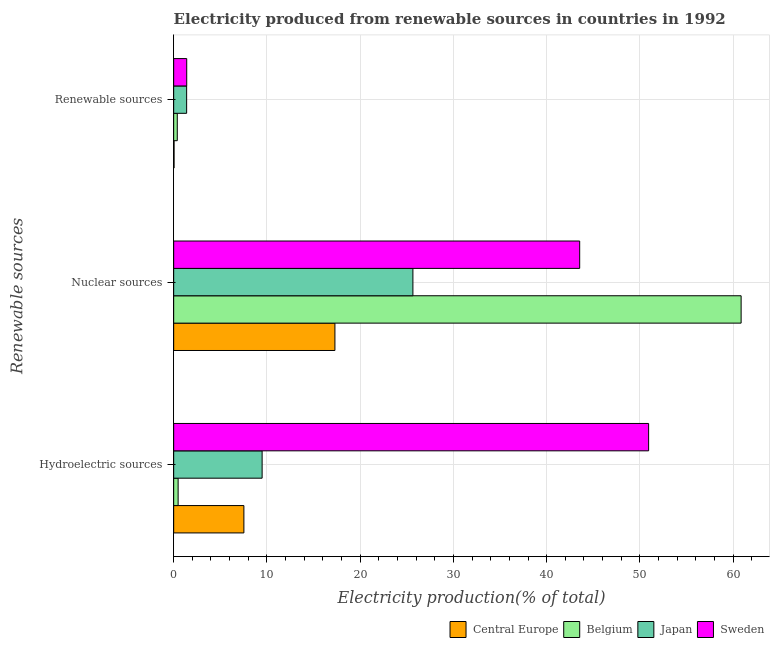Are the number of bars on each tick of the Y-axis equal?
Make the answer very short. Yes. What is the label of the 2nd group of bars from the top?
Offer a very short reply. Nuclear sources. What is the percentage of electricity produced by nuclear sources in Belgium?
Offer a terse response. 60.85. Across all countries, what is the maximum percentage of electricity produced by renewable sources?
Make the answer very short. 1.4. Across all countries, what is the minimum percentage of electricity produced by renewable sources?
Offer a very short reply. 0.04. In which country was the percentage of electricity produced by nuclear sources minimum?
Your response must be concise. Central Europe. What is the total percentage of electricity produced by nuclear sources in the graph?
Your answer should be very brief. 147.34. What is the difference between the percentage of electricity produced by renewable sources in Sweden and that in Central Europe?
Provide a succinct answer. 1.36. What is the difference between the percentage of electricity produced by hydroelectric sources in Central Europe and the percentage of electricity produced by renewable sources in Japan?
Keep it short and to the point. 6.14. What is the average percentage of electricity produced by renewable sources per country?
Keep it short and to the point. 0.8. What is the difference between the percentage of electricity produced by nuclear sources and percentage of electricity produced by hydroelectric sources in Central Europe?
Keep it short and to the point. 9.76. In how many countries, is the percentage of electricity produced by nuclear sources greater than 48 %?
Make the answer very short. 1. What is the ratio of the percentage of electricity produced by nuclear sources in Japan to that in Belgium?
Keep it short and to the point. 0.42. Is the percentage of electricity produced by hydroelectric sources in Sweden less than that in Belgium?
Make the answer very short. No. Is the difference between the percentage of electricity produced by nuclear sources in Sweden and Japan greater than the difference between the percentage of electricity produced by renewable sources in Sweden and Japan?
Provide a short and direct response. Yes. What is the difference between the highest and the second highest percentage of electricity produced by renewable sources?
Ensure brevity in your answer.  0.01. What is the difference between the highest and the lowest percentage of electricity produced by hydroelectric sources?
Offer a very short reply. 50.46. In how many countries, is the percentage of electricity produced by hydroelectric sources greater than the average percentage of electricity produced by hydroelectric sources taken over all countries?
Provide a succinct answer. 1. What does the 1st bar from the bottom in Hydroelectric sources represents?
Provide a succinct answer. Central Europe. Is it the case that in every country, the sum of the percentage of electricity produced by hydroelectric sources and percentage of electricity produced by nuclear sources is greater than the percentage of electricity produced by renewable sources?
Your response must be concise. Yes. How many bars are there?
Offer a terse response. 12. How many countries are there in the graph?
Give a very brief answer. 4. What is the difference between two consecutive major ticks on the X-axis?
Make the answer very short. 10. Are the values on the major ticks of X-axis written in scientific E-notation?
Provide a short and direct response. No. Does the graph contain grids?
Make the answer very short. Yes. How are the legend labels stacked?
Provide a short and direct response. Horizontal. What is the title of the graph?
Keep it short and to the point. Electricity produced from renewable sources in countries in 1992. What is the label or title of the X-axis?
Ensure brevity in your answer.  Electricity production(% of total). What is the label or title of the Y-axis?
Offer a terse response. Renewable sources. What is the Electricity production(% of total) in Central Europe in Hydroelectric sources?
Ensure brevity in your answer.  7.53. What is the Electricity production(% of total) in Belgium in Hydroelectric sources?
Ensure brevity in your answer.  0.48. What is the Electricity production(% of total) in Japan in Hydroelectric sources?
Give a very brief answer. 9.49. What is the Electricity production(% of total) of Sweden in Hydroelectric sources?
Your response must be concise. 50.93. What is the Electricity production(% of total) in Central Europe in Nuclear sources?
Your answer should be compact. 17.29. What is the Electricity production(% of total) of Belgium in Nuclear sources?
Provide a short and direct response. 60.85. What is the Electricity production(% of total) in Japan in Nuclear sources?
Your response must be concise. 25.65. What is the Electricity production(% of total) of Sweden in Nuclear sources?
Your response must be concise. 43.54. What is the Electricity production(% of total) in Central Europe in Renewable sources?
Keep it short and to the point. 0.04. What is the Electricity production(% of total) of Belgium in Renewable sources?
Keep it short and to the point. 0.39. What is the Electricity production(% of total) of Japan in Renewable sources?
Offer a terse response. 1.39. What is the Electricity production(% of total) of Sweden in Renewable sources?
Ensure brevity in your answer.  1.4. Across all Renewable sources, what is the maximum Electricity production(% of total) of Central Europe?
Ensure brevity in your answer.  17.29. Across all Renewable sources, what is the maximum Electricity production(% of total) of Belgium?
Provide a succinct answer. 60.85. Across all Renewable sources, what is the maximum Electricity production(% of total) in Japan?
Ensure brevity in your answer.  25.65. Across all Renewable sources, what is the maximum Electricity production(% of total) of Sweden?
Make the answer very short. 50.93. Across all Renewable sources, what is the minimum Electricity production(% of total) of Central Europe?
Offer a terse response. 0.04. Across all Renewable sources, what is the minimum Electricity production(% of total) of Belgium?
Offer a terse response. 0.39. Across all Renewable sources, what is the minimum Electricity production(% of total) in Japan?
Provide a short and direct response. 1.39. Across all Renewable sources, what is the minimum Electricity production(% of total) in Sweden?
Provide a succinct answer. 1.4. What is the total Electricity production(% of total) of Central Europe in the graph?
Ensure brevity in your answer.  24.87. What is the total Electricity production(% of total) in Belgium in the graph?
Your answer should be very brief. 61.72. What is the total Electricity production(% of total) of Japan in the graph?
Offer a very short reply. 36.53. What is the total Electricity production(% of total) in Sweden in the graph?
Offer a very short reply. 95.88. What is the difference between the Electricity production(% of total) in Central Europe in Hydroelectric sources and that in Nuclear sources?
Your answer should be very brief. -9.76. What is the difference between the Electricity production(% of total) in Belgium in Hydroelectric sources and that in Nuclear sources?
Offer a very short reply. -60.38. What is the difference between the Electricity production(% of total) in Japan in Hydroelectric sources and that in Nuclear sources?
Provide a succinct answer. -16.17. What is the difference between the Electricity production(% of total) of Sweden in Hydroelectric sources and that in Nuclear sources?
Offer a very short reply. 7.39. What is the difference between the Electricity production(% of total) in Central Europe in Hydroelectric sources and that in Renewable sources?
Your response must be concise. 7.49. What is the difference between the Electricity production(% of total) in Belgium in Hydroelectric sources and that in Renewable sources?
Provide a short and direct response. 0.09. What is the difference between the Electricity production(% of total) in Japan in Hydroelectric sources and that in Renewable sources?
Offer a terse response. 8.09. What is the difference between the Electricity production(% of total) of Sweden in Hydroelectric sources and that in Renewable sources?
Your answer should be very brief. 49.54. What is the difference between the Electricity production(% of total) in Central Europe in Nuclear sources and that in Renewable sources?
Provide a short and direct response. 17.25. What is the difference between the Electricity production(% of total) in Belgium in Nuclear sources and that in Renewable sources?
Your response must be concise. 60.47. What is the difference between the Electricity production(% of total) in Japan in Nuclear sources and that in Renewable sources?
Give a very brief answer. 24.26. What is the difference between the Electricity production(% of total) in Sweden in Nuclear sources and that in Renewable sources?
Your answer should be very brief. 42.14. What is the difference between the Electricity production(% of total) of Central Europe in Hydroelectric sources and the Electricity production(% of total) of Belgium in Nuclear sources?
Keep it short and to the point. -53.32. What is the difference between the Electricity production(% of total) in Central Europe in Hydroelectric sources and the Electricity production(% of total) in Japan in Nuclear sources?
Give a very brief answer. -18.12. What is the difference between the Electricity production(% of total) of Central Europe in Hydroelectric sources and the Electricity production(% of total) of Sweden in Nuclear sources?
Your response must be concise. -36.01. What is the difference between the Electricity production(% of total) in Belgium in Hydroelectric sources and the Electricity production(% of total) in Japan in Nuclear sources?
Keep it short and to the point. -25.18. What is the difference between the Electricity production(% of total) of Belgium in Hydroelectric sources and the Electricity production(% of total) of Sweden in Nuclear sources?
Ensure brevity in your answer.  -43.06. What is the difference between the Electricity production(% of total) of Japan in Hydroelectric sources and the Electricity production(% of total) of Sweden in Nuclear sources?
Provide a succinct answer. -34.06. What is the difference between the Electricity production(% of total) in Central Europe in Hydroelectric sources and the Electricity production(% of total) in Belgium in Renewable sources?
Ensure brevity in your answer.  7.14. What is the difference between the Electricity production(% of total) in Central Europe in Hydroelectric sources and the Electricity production(% of total) in Japan in Renewable sources?
Provide a short and direct response. 6.14. What is the difference between the Electricity production(% of total) in Central Europe in Hydroelectric sources and the Electricity production(% of total) in Sweden in Renewable sources?
Provide a short and direct response. 6.13. What is the difference between the Electricity production(% of total) in Belgium in Hydroelectric sources and the Electricity production(% of total) in Japan in Renewable sources?
Offer a very short reply. -0.91. What is the difference between the Electricity production(% of total) of Belgium in Hydroelectric sources and the Electricity production(% of total) of Sweden in Renewable sources?
Your response must be concise. -0.92. What is the difference between the Electricity production(% of total) of Japan in Hydroelectric sources and the Electricity production(% of total) of Sweden in Renewable sources?
Your answer should be compact. 8.09. What is the difference between the Electricity production(% of total) of Central Europe in Nuclear sources and the Electricity production(% of total) of Belgium in Renewable sources?
Make the answer very short. 16.91. What is the difference between the Electricity production(% of total) of Central Europe in Nuclear sources and the Electricity production(% of total) of Japan in Renewable sources?
Your answer should be very brief. 15.9. What is the difference between the Electricity production(% of total) in Central Europe in Nuclear sources and the Electricity production(% of total) in Sweden in Renewable sources?
Ensure brevity in your answer.  15.89. What is the difference between the Electricity production(% of total) of Belgium in Nuclear sources and the Electricity production(% of total) of Japan in Renewable sources?
Keep it short and to the point. 59.46. What is the difference between the Electricity production(% of total) of Belgium in Nuclear sources and the Electricity production(% of total) of Sweden in Renewable sources?
Provide a short and direct response. 59.46. What is the difference between the Electricity production(% of total) in Japan in Nuclear sources and the Electricity production(% of total) in Sweden in Renewable sources?
Offer a terse response. 24.26. What is the average Electricity production(% of total) of Central Europe per Renewable sources?
Make the answer very short. 8.29. What is the average Electricity production(% of total) of Belgium per Renewable sources?
Your answer should be very brief. 20.57. What is the average Electricity production(% of total) of Japan per Renewable sources?
Make the answer very short. 12.18. What is the average Electricity production(% of total) of Sweden per Renewable sources?
Your response must be concise. 31.96. What is the difference between the Electricity production(% of total) in Central Europe and Electricity production(% of total) in Belgium in Hydroelectric sources?
Your response must be concise. 7.05. What is the difference between the Electricity production(% of total) of Central Europe and Electricity production(% of total) of Japan in Hydroelectric sources?
Ensure brevity in your answer.  -1.95. What is the difference between the Electricity production(% of total) in Central Europe and Electricity production(% of total) in Sweden in Hydroelectric sources?
Ensure brevity in your answer.  -43.4. What is the difference between the Electricity production(% of total) in Belgium and Electricity production(% of total) in Japan in Hydroelectric sources?
Make the answer very short. -9.01. What is the difference between the Electricity production(% of total) of Belgium and Electricity production(% of total) of Sweden in Hydroelectric sources?
Give a very brief answer. -50.46. What is the difference between the Electricity production(% of total) in Japan and Electricity production(% of total) in Sweden in Hydroelectric sources?
Provide a succinct answer. -41.45. What is the difference between the Electricity production(% of total) of Central Europe and Electricity production(% of total) of Belgium in Nuclear sources?
Keep it short and to the point. -43.56. What is the difference between the Electricity production(% of total) in Central Europe and Electricity production(% of total) in Japan in Nuclear sources?
Ensure brevity in your answer.  -8.36. What is the difference between the Electricity production(% of total) of Central Europe and Electricity production(% of total) of Sweden in Nuclear sources?
Offer a very short reply. -26.25. What is the difference between the Electricity production(% of total) of Belgium and Electricity production(% of total) of Japan in Nuclear sources?
Provide a short and direct response. 35.2. What is the difference between the Electricity production(% of total) of Belgium and Electricity production(% of total) of Sweden in Nuclear sources?
Offer a terse response. 17.31. What is the difference between the Electricity production(% of total) of Japan and Electricity production(% of total) of Sweden in Nuclear sources?
Provide a short and direct response. -17.89. What is the difference between the Electricity production(% of total) of Central Europe and Electricity production(% of total) of Belgium in Renewable sources?
Provide a succinct answer. -0.34. What is the difference between the Electricity production(% of total) of Central Europe and Electricity production(% of total) of Japan in Renewable sources?
Make the answer very short. -1.35. What is the difference between the Electricity production(% of total) of Central Europe and Electricity production(% of total) of Sweden in Renewable sources?
Provide a short and direct response. -1.36. What is the difference between the Electricity production(% of total) in Belgium and Electricity production(% of total) in Japan in Renewable sources?
Give a very brief answer. -1. What is the difference between the Electricity production(% of total) of Belgium and Electricity production(% of total) of Sweden in Renewable sources?
Keep it short and to the point. -1.01. What is the difference between the Electricity production(% of total) of Japan and Electricity production(% of total) of Sweden in Renewable sources?
Make the answer very short. -0.01. What is the ratio of the Electricity production(% of total) of Central Europe in Hydroelectric sources to that in Nuclear sources?
Make the answer very short. 0.44. What is the ratio of the Electricity production(% of total) of Belgium in Hydroelectric sources to that in Nuclear sources?
Offer a very short reply. 0.01. What is the ratio of the Electricity production(% of total) of Japan in Hydroelectric sources to that in Nuclear sources?
Your answer should be very brief. 0.37. What is the ratio of the Electricity production(% of total) of Sweden in Hydroelectric sources to that in Nuclear sources?
Your answer should be very brief. 1.17. What is the ratio of the Electricity production(% of total) of Central Europe in Hydroelectric sources to that in Renewable sources?
Give a very brief answer. 177.96. What is the ratio of the Electricity production(% of total) of Belgium in Hydroelectric sources to that in Renewable sources?
Your answer should be compact. 1.24. What is the ratio of the Electricity production(% of total) of Japan in Hydroelectric sources to that in Renewable sources?
Provide a short and direct response. 6.82. What is the ratio of the Electricity production(% of total) in Sweden in Hydroelectric sources to that in Renewable sources?
Your answer should be compact. 36.42. What is the ratio of the Electricity production(% of total) in Central Europe in Nuclear sources to that in Renewable sources?
Ensure brevity in your answer.  408.64. What is the ratio of the Electricity production(% of total) in Belgium in Nuclear sources to that in Renewable sources?
Provide a succinct answer. 157.45. What is the ratio of the Electricity production(% of total) of Japan in Nuclear sources to that in Renewable sources?
Offer a terse response. 18.45. What is the ratio of the Electricity production(% of total) in Sweden in Nuclear sources to that in Renewable sources?
Give a very brief answer. 31.13. What is the difference between the highest and the second highest Electricity production(% of total) of Central Europe?
Offer a terse response. 9.76. What is the difference between the highest and the second highest Electricity production(% of total) of Belgium?
Your answer should be very brief. 60.38. What is the difference between the highest and the second highest Electricity production(% of total) in Japan?
Your answer should be very brief. 16.17. What is the difference between the highest and the second highest Electricity production(% of total) in Sweden?
Ensure brevity in your answer.  7.39. What is the difference between the highest and the lowest Electricity production(% of total) in Central Europe?
Make the answer very short. 17.25. What is the difference between the highest and the lowest Electricity production(% of total) of Belgium?
Your answer should be compact. 60.47. What is the difference between the highest and the lowest Electricity production(% of total) of Japan?
Your answer should be very brief. 24.26. What is the difference between the highest and the lowest Electricity production(% of total) in Sweden?
Your response must be concise. 49.54. 